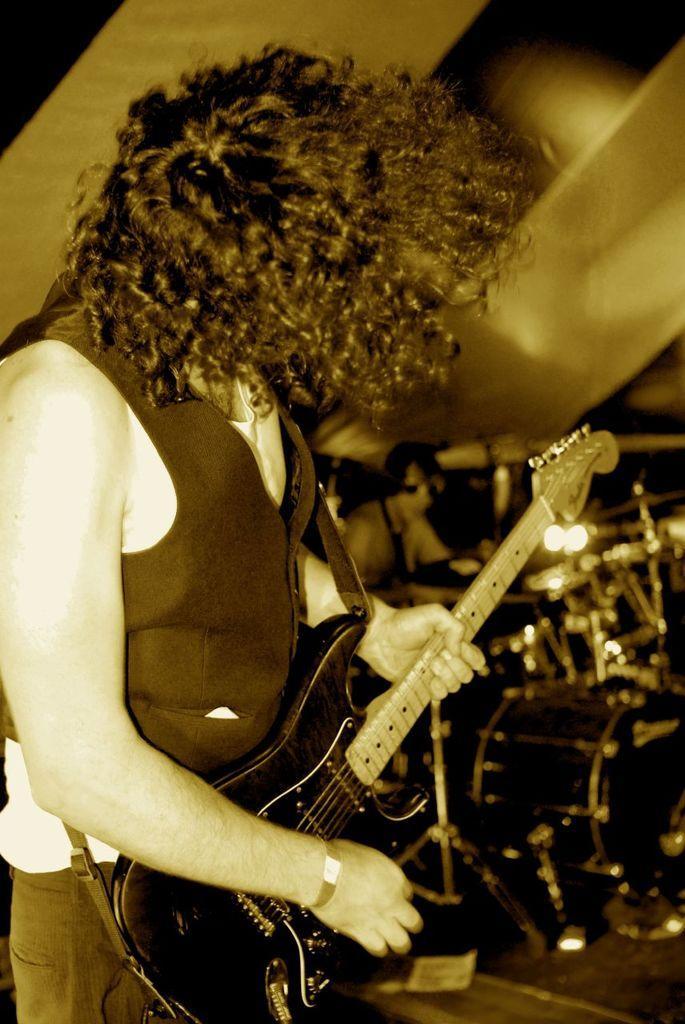Please provide a concise description of this image. In this picture there are two musicians. The man at the left corner of the image is holding guitar. He has long hair and is wearing vest. The man behind him is playing drums. On the floor there are many drums and drum stands. In the background there is wall. 